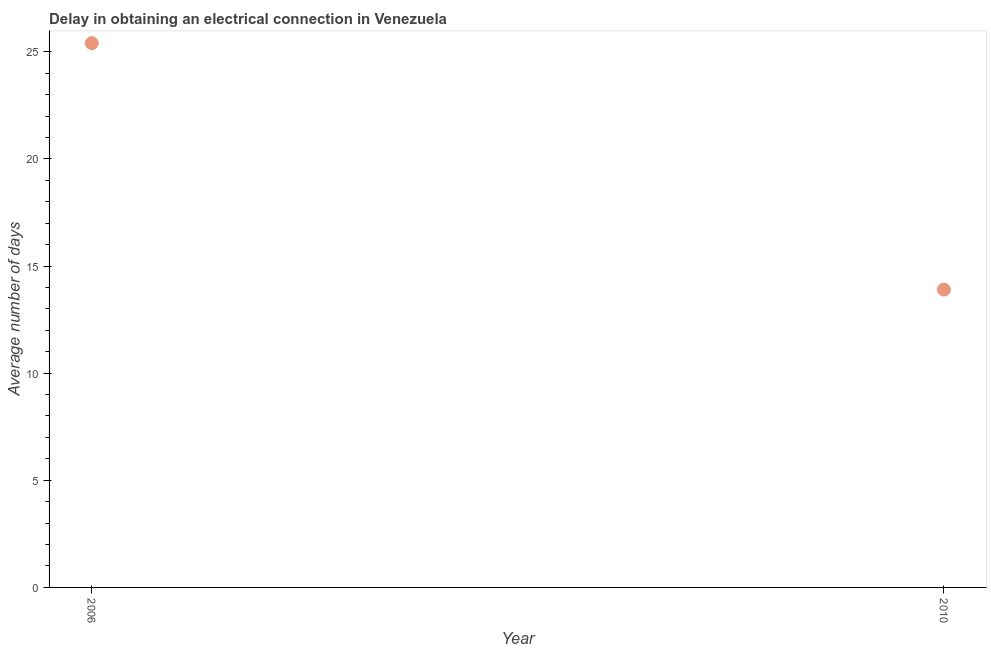What is the dalay in electrical connection in 2006?
Your answer should be very brief. 25.4. Across all years, what is the maximum dalay in electrical connection?
Your answer should be compact. 25.4. What is the sum of the dalay in electrical connection?
Ensure brevity in your answer.  39.3. What is the difference between the dalay in electrical connection in 2006 and 2010?
Your answer should be very brief. 11.5. What is the average dalay in electrical connection per year?
Keep it short and to the point. 19.65. What is the median dalay in electrical connection?
Provide a succinct answer. 19.65. In how many years, is the dalay in electrical connection greater than 20 days?
Your answer should be very brief. 1. Do a majority of the years between 2006 and 2010 (inclusive) have dalay in electrical connection greater than 6 days?
Give a very brief answer. Yes. What is the ratio of the dalay in electrical connection in 2006 to that in 2010?
Make the answer very short. 1.83. Is the dalay in electrical connection in 2006 less than that in 2010?
Provide a succinct answer. No. In how many years, is the dalay in electrical connection greater than the average dalay in electrical connection taken over all years?
Offer a very short reply. 1. How many dotlines are there?
Your response must be concise. 1. How many years are there in the graph?
Offer a terse response. 2. Does the graph contain grids?
Offer a terse response. No. What is the title of the graph?
Your answer should be compact. Delay in obtaining an electrical connection in Venezuela. What is the label or title of the X-axis?
Your answer should be compact. Year. What is the label or title of the Y-axis?
Your response must be concise. Average number of days. What is the Average number of days in 2006?
Make the answer very short. 25.4. What is the Average number of days in 2010?
Ensure brevity in your answer.  13.9. What is the ratio of the Average number of days in 2006 to that in 2010?
Ensure brevity in your answer.  1.83. 